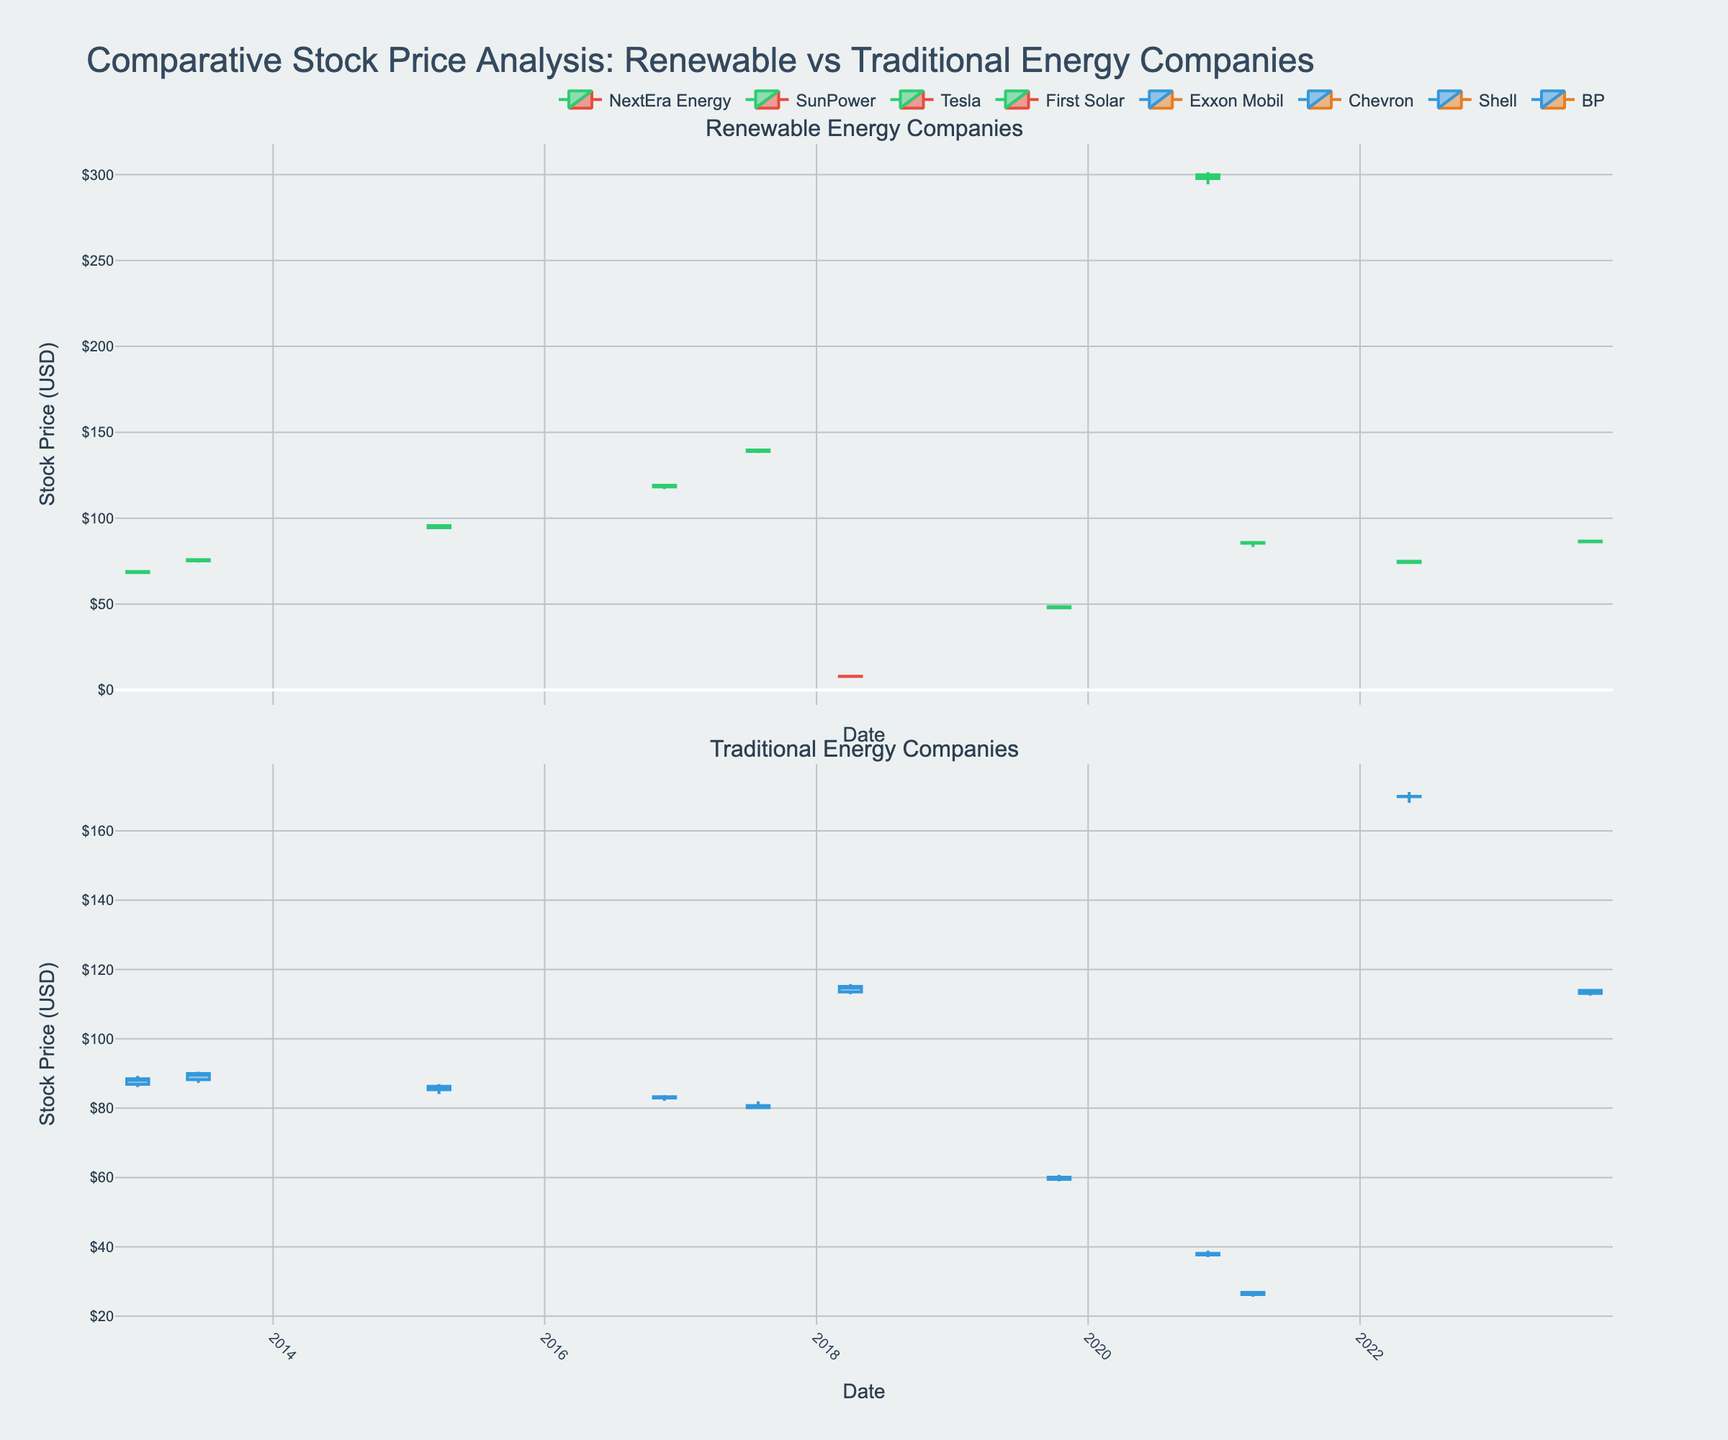What type of companies does the figure compare? The figure has two subplots, each titled to reflect different groups of companies. The top subplot is titled "Renewable Energy Companies," and the bottom one is titled "Traditional Energy Companies."
Answer: Renewable energy and traditional energy companies What are the stock prices on 2013-01-02 for NextEra Energy and Exxon Mobil, and which stock was higher? For 2013-01-02, the candlestick of NextEra Energy shows a close price of 68.92 USD, and Exxon Mobil shows a close price of 88.50 USD. Comparing these, Exxon's stock price is higher.
Answer: Exxon Mobil Which company shows the highest closing price in the data provided, and what is that price? To find this, we look at the candlesticks for each stock and identify the highest closing price. The subplot shows NextEra Energy with a closing price of 299.87 USD on 2020-11-18.
Answer: NextEra Energy, 299.87 USD Between 2013 and 2023, which company had a significant increase in their stock price, and is it a renewable or traditional company? By comparing the first and last data points of each company, NextEra Energy shows a significant increase from 68.92 USD (2013) to 299.87 USD (2020). It is a renewable energy company.
Answer: NextEra Energy, Renewable How did Chevron's stock price change between 2018-04-02 and 2022-05-13? On 2018-04-02, Chevron closed at 115.12 USD, and on 2022-05-13, it closed at 169.95 USD. The change is calculated as 169.95 - 115.12.
Answer: Increase by 54.83 USD How many companies are plotted in each subplot? By counting the unique companies in each subplot, we observe that there are five renewable energy companies and six traditional energy companies.
Answer: Five in renewable, six in traditional Compare the largest and smallest movements for any company within a single day. Which movement is larger, and what is the difference? To compare movements, we look at the highest and lowest prices for each company on any given day. For instance, NextEra Energy on 2020-11-18 had a high of 301.50 USD and a low of 294.30 USD, a range of 7.20 USD. The largest movements are compared to find the highest difference.
Answer: NextEra Energy, 7.20 USD During what date did we see the highest trading volume and for which company? Check the volume data points for each registered date. The highest volume is 38437000 for Exxon Mobil on 2013-01-02.
Answer: 2013-01-02, Exxon Mobil 